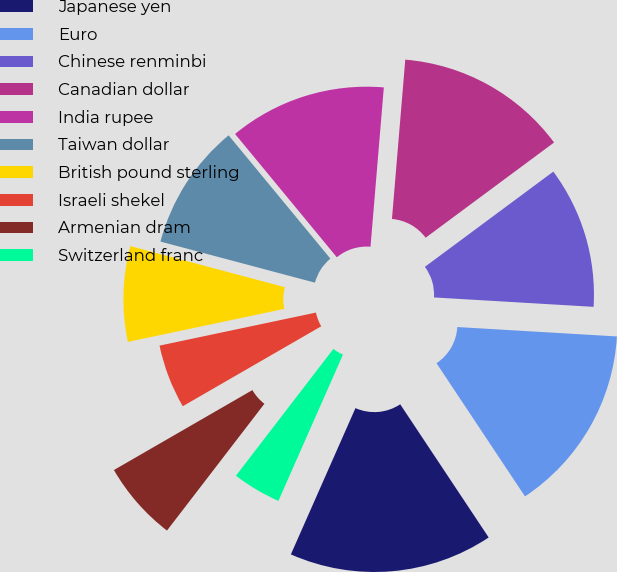Convert chart. <chart><loc_0><loc_0><loc_500><loc_500><pie_chart><fcel>Japanese yen<fcel>Euro<fcel>Chinese renminbi<fcel>Canadian dollar<fcel>India rupee<fcel>Taiwan dollar<fcel>British pound sterling<fcel>Israeli shekel<fcel>Armenian dram<fcel>Switzerland franc<nl><fcel>15.95%<fcel>14.73%<fcel>11.09%<fcel>13.52%<fcel>12.31%<fcel>9.88%<fcel>7.45%<fcel>5.02%<fcel>6.24%<fcel>3.81%<nl></chart> 